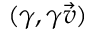<formula> <loc_0><loc_0><loc_500><loc_500>( \gamma , \gamma { \vec { v } } )</formula> 